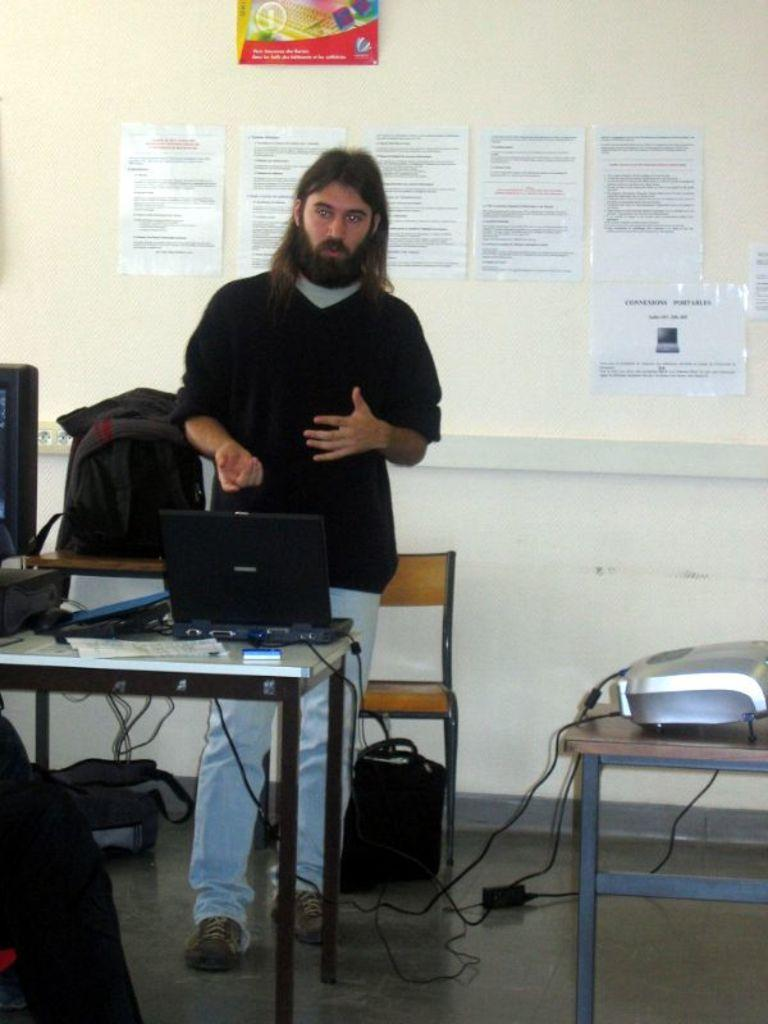Who is present in the image? There is a man in the image. What is the man doing in the image? The man is standing in the image. What object can be seen on the table in the image? There is a laptop on the table in the image. What color is the silverware on the table in the image? There is no silverware present in the image; only a laptop is visible on the table. 